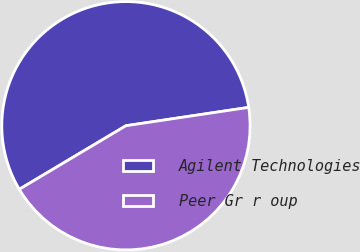Convert chart. <chart><loc_0><loc_0><loc_500><loc_500><pie_chart><fcel>Agilent Technologies<fcel>Peer Gr r oup<nl><fcel>56.19%<fcel>43.81%<nl></chart> 